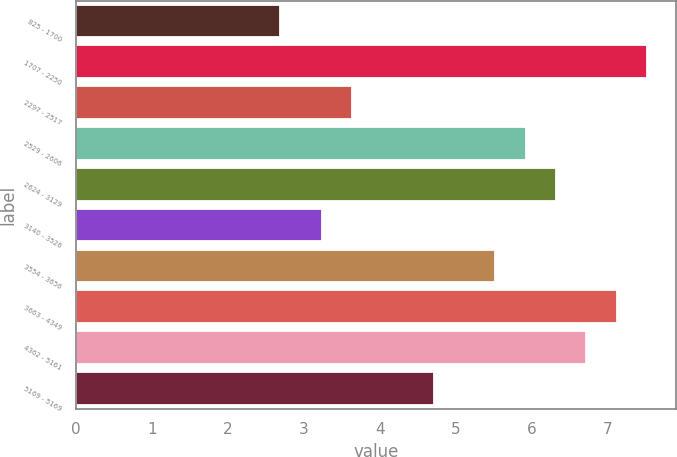Convert chart to OTSL. <chart><loc_0><loc_0><loc_500><loc_500><bar_chart><fcel>825 - 1700<fcel>1707 - 2250<fcel>2297 - 2517<fcel>2529 - 2606<fcel>2624 - 3129<fcel>3140 - 3526<fcel>3554 - 3656<fcel>3663 - 4349<fcel>4362 - 5161<fcel>5169 - 5169<nl><fcel>2.69<fcel>7.52<fcel>3.64<fcel>5.92<fcel>6.32<fcel>3.24<fcel>5.52<fcel>7.12<fcel>6.72<fcel>4.72<nl></chart> 